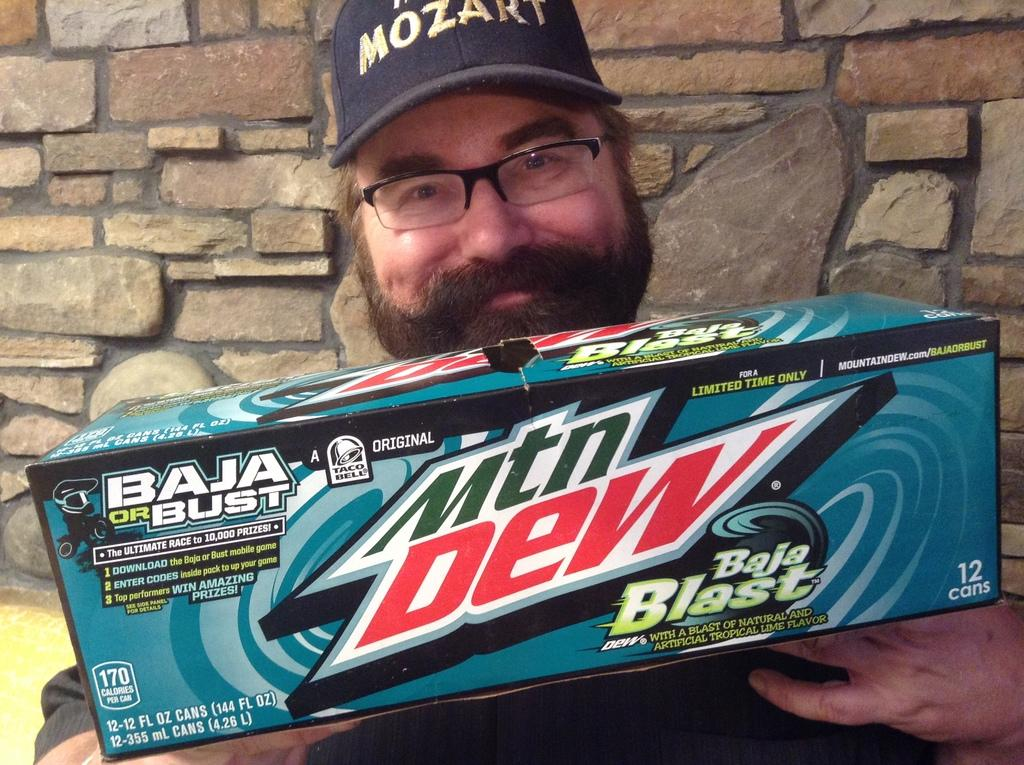Who is present in the image? There is a man in the image. What is the man holding in the image? The man is holding a Mountain Dew box. What can be seen in the background of the image? There is a brick wall in the background of the image. How many tomatoes are growing on the brick wall in the image? There are no tomatoes present in the image, and the brick wall does not have any plants growing on it. 